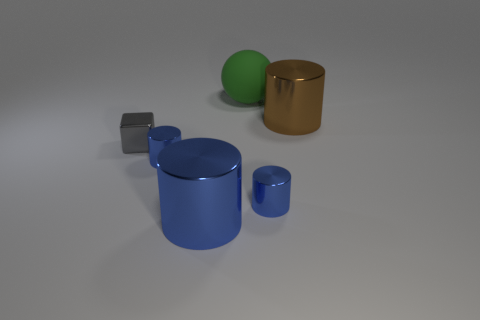Subtract all brown balls. How many blue cylinders are left? 3 Subtract all big blue cylinders. How many cylinders are left? 3 Subtract all brown cylinders. How many cylinders are left? 3 Subtract 1 cylinders. How many cylinders are left? 3 Add 2 big blue metallic things. How many objects exist? 8 Subtract all cylinders. How many objects are left? 2 Subtract all red cylinders. Subtract all blue cubes. How many cylinders are left? 4 Subtract all large blue objects. Subtract all big metal objects. How many objects are left? 3 Add 3 large blue things. How many large blue things are left? 4 Add 3 large green rubber balls. How many large green rubber balls exist? 4 